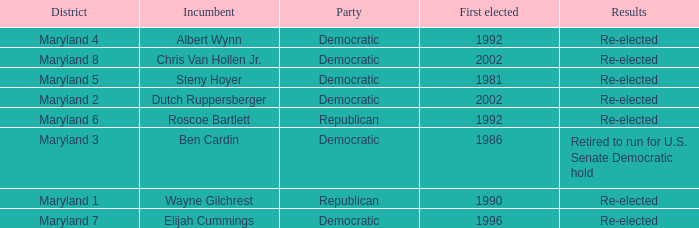What are the results of the incumbent who was first elected in 1996? Re-elected. 